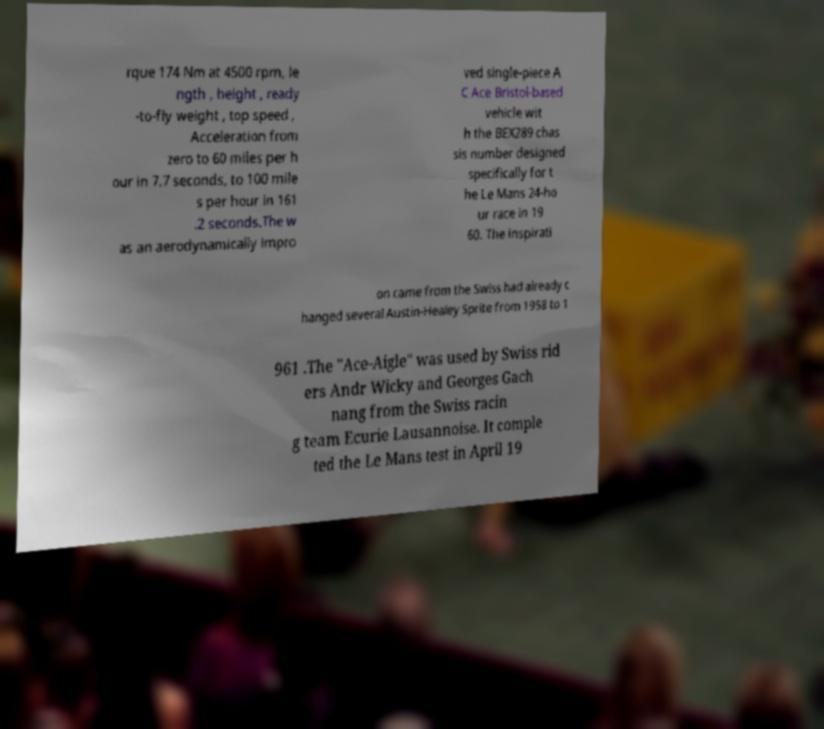Can you accurately transcribe the text from the provided image for me? rque 174 Nm at 4500 rpm, le ngth , height , ready -to-fly weight , top speed , Acceleration from zero to 60 miles per h our in 7.7 seconds, to 100 mile s per hour in 161 .2 seconds.The w as an aerodynamically impro ved single-piece A C Ace Bristol-based vehicle wit h the BEX289 chas sis number designed specifically for t he Le Mans 24-ho ur race in 19 60. The inspirati on came from the Swiss had already c hanged several Austin-Healey Sprite from 1958 to 1 961 .The "Ace-Aigle" was used by Swiss rid ers Andr Wicky and Georges Gach nang from the Swiss racin g team Ecurie Lausannoise. It comple ted the Le Mans test in April 19 